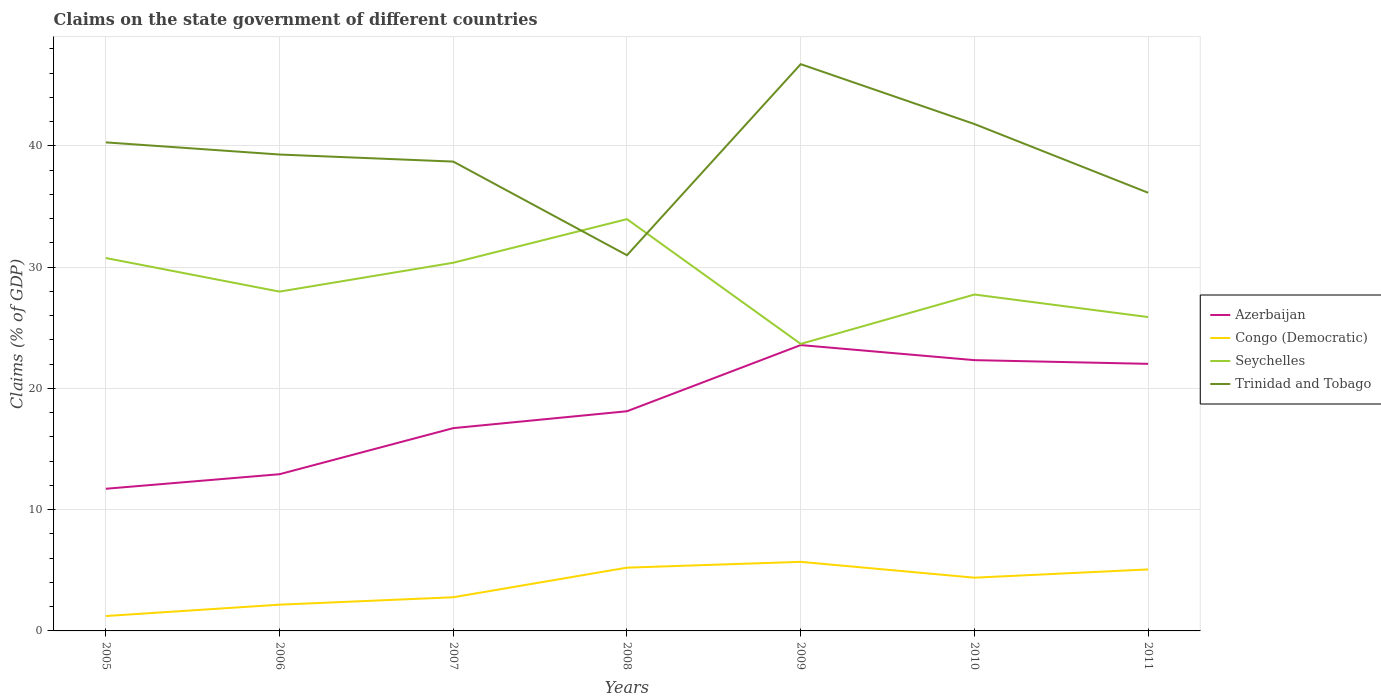How many different coloured lines are there?
Your response must be concise. 4. Does the line corresponding to Congo (Democratic) intersect with the line corresponding to Azerbaijan?
Your response must be concise. No. Is the number of lines equal to the number of legend labels?
Your response must be concise. Yes. Across all years, what is the maximum percentage of GDP claimed on the state government in Congo (Democratic)?
Provide a short and direct response. 1.23. What is the total percentage of GDP claimed on the state government in Trinidad and Tobago in the graph?
Your response must be concise. 2.57. What is the difference between the highest and the second highest percentage of GDP claimed on the state government in Trinidad and Tobago?
Make the answer very short. 15.76. What is the difference between the highest and the lowest percentage of GDP claimed on the state government in Congo (Democratic)?
Provide a succinct answer. 4. How many lines are there?
Keep it short and to the point. 4. How many years are there in the graph?
Your answer should be compact. 7. What is the difference between two consecutive major ticks on the Y-axis?
Offer a terse response. 10. Does the graph contain any zero values?
Keep it short and to the point. No. Where does the legend appear in the graph?
Provide a succinct answer. Center right. What is the title of the graph?
Give a very brief answer. Claims on the state government of different countries. What is the label or title of the Y-axis?
Keep it short and to the point. Claims (% of GDP). What is the Claims (% of GDP) of Azerbaijan in 2005?
Your answer should be very brief. 11.73. What is the Claims (% of GDP) in Congo (Democratic) in 2005?
Ensure brevity in your answer.  1.23. What is the Claims (% of GDP) in Seychelles in 2005?
Offer a very short reply. 30.76. What is the Claims (% of GDP) of Trinidad and Tobago in 2005?
Keep it short and to the point. 40.29. What is the Claims (% of GDP) in Azerbaijan in 2006?
Your answer should be compact. 12.93. What is the Claims (% of GDP) of Congo (Democratic) in 2006?
Give a very brief answer. 2.16. What is the Claims (% of GDP) of Seychelles in 2006?
Make the answer very short. 27.99. What is the Claims (% of GDP) in Trinidad and Tobago in 2006?
Ensure brevity in your answer.  39.29. What is the Claims (% of GDP) of Azerbaijan in 2007?
Your answer should be compact. 16.73. What is the Claims (% of GDP) in Congo (Democratic) in 2007?
Give a very brief answer. 2.78. What is the Claims (% of GDP) in Seychelles in 2007?
Your answer should be compact. 30.37. What is the Claims (% of GDP) in Trinidad and Tobago in 2007?
Give a very brief answer. 38.71. What is the Claims (% of GDP) of Azerbaijan in 2008?
Offer a terse response. 18.12. What is the Claims (% of GDP) of Congo (Democratic) in 2008?
Offer a very short reply. 5.22. What is the Claims (% of GDP) of Seychelles in 2008?
Give a very brief answer. 33.96. What is the Claims (% of GDP) in Trinidad and Tobago in 2008?
Provide a short and direct response. 30.99. What is the Claims (% of GDP) in Azerbaijan in 2009?
Offer a very short reply. 23.58. What is the Claims (% of GDP) in Congo (Democratic) in 2009?
Your answer should be compact. 5.7. What is the Claims (% of GDP) of Seychelles in 2009?
Your answer should be compact. 23.67. What is the Claims (% of GDP) in Trinidad and Tobago in 2009?
Provide a short and direct response. 46.75. What is the Claims (% of GDP) in Azerbaijan in 2010?
Your answer should be compact. 22.33. What is the Claims (% of GDP) in Congo (Democratic) in 2010?
Make the answer very short. 4.39. What is the Claims (% of GDP) in Seychelles in 2010?
Provide a short and direct response. 27.75. What is the Claims (% of GDP) in Trinidad and Tobago in 2010?
Provide a succinct answer. 41.81. What is the Claims (% of GDP) of Azerbaijan in 2011?
Provide a short and direct response. 22.03. What is the Claims (% of GDP) of Congo (Democratic) in 2011?
Your response must be concise. 5.07. What is the Claims (% of GDP) of Seychelles in 2011?
Ensure brevity in your answer.  25.89. What is the Claims (% of GDP) of Trinidad and Tobago in 2011?
Ensure brevity in your answer.  36.14. Across all years, what is the maximum Claims (% of GDP) in Azerbaijan?
Your answer should be compact. 23.58. Across all years, what is the maximum Claims (% of GDP) in Congo (Democratic)?
Give a very brief answer. 5.7. Across all years, what is the maximum Claims (% of GDP) in Seychelles?
Make the answer very short. 33.96. Across all years, what is the maximum Claims (% of GDP) in Trinidad and Tobago?
Offer a very short reply. 46.75. Across all years, what is the minimum Claims (% of GDP) of Azerbaijan?
Make the answer very short. 11.73. Across all years, what is the minimum Claims (% of GDP) of Congo (Democratic)?
Make the answer very short. 1.23. Across all years, what is the minimum Claims (% of GDP) in Seychelles?
Your answer should be compact. 23.67. Across all years, what is the minimum Claims (% of GDP) of Trinidad and Tobago?
Offer a terse response. 30.99. What is the total Claims (% of GDP) of Azerbaijan in the graph?
Provide a succinct answer. 127.43. What is the total Claims (% of GDP) of Congo (Democratic) in the graph?
Offer a terse response. 26.55. What is the total Claims (% of GDP) of Seychelles in the graph?
Your response must be concise. 200.38. What is the total Claims (% of GDP) of Trinidad and Tobago in the graph?
Your response must be concise. 273.98. What is the difference between the Claims (% of GDP) in Azerbaijan in 2005 and that in 2006?
Your answer should be very brief. -1.2. What is the difference between the Claims (% of GDP) in Congo (Democratic) in 2005 and that in 2006?
Your response must be concise. -0.94. What is the difference between the Claims (% of GDP) of Seychelles in 2005 and that in 2006?
Your response must be concise. 2.77. What is the difference between the Claims (% of GDP) in Trinidad and Tobago in 2005 and that in 2006?
Your response must be concise. 1. What is the difference between the Claims (% of GDP) in Azerbaijan in 2005 and that in 2007?
Provide a short and direct response. -5. What is the difference between the Claims (% of GDP) of Congo (Democratic) in 2005 and that in 2007?
Offer a terse response. -1.55. What is the difference between the Claims (% of GDP) of Seychelles in 2005 and that in 2007?
Give a very brief answer. 0.39. What is the difference between the Claims (% of GDP) of Trinidad and Tobago in 2005 and that in 2007?
Your answer should be very brief. 1.58. What is the difference between the Claims (% of GDP) in Azerbaijan in 2005 and that in 2008?
Offer a terse response. -6.39. What is the difference between the Claims (% of GDP) in Congo (Democratic) in 2005 and that in 2008?
Offer a very short reply. -3.99. What is the difference between the Claims (% of GDP) of Seychelles in 2005 and that in 2008?
Offer a terse response. -3.21. What is the difference between the Claims (% of GDP) of Trinidad and Tobago in 2005 and that in 2008?
Your response must be concise. 9.31. What is the difference between the Claims (% of GDP) of Azerbaijan in 2005 and that in 2009?
Provide a short and direct response. -11.85. What is the difference between the Claims (% of GDP) in Congo (Democratic) in 2005 and that in 2009?
Keep it short and to the point. -4.47. What is the difference between the Claims (% of GDP) in Seychelles in 2005 and that in 2009?
Your answer should be compact. 7.08. What is the difference between the Claims (% of GDP) of Trinidad and Tobago in 2005 and that in 2009?
Ensure brevity in your answer.  -6.45. What is the difference between the Claims (% of GDP) of Azerbaijan in 2005 and that in 2010?
Offer a very short reply. -10.61. What is the difference between the Claims (% of GDP) of Congo (Democratic) in 2005 and that in 2010?
Make the answer very short. -3.16. What is the difference between the Claims (% of GDP) in Seychelles in 2005 and that in 2010?
Make the answer very short. 3.01. What is the difference between the Claims (% of GDP) of Trinidad and Tobago in 2005 and that in 2010?
Ensure brevity in your answer.  -1.51. What is the difference between the Claims (% of GDP) of Azerbaijan in 2005 and that in 2011?
Your answer should be very brief. -10.3. What is the difference between the Claims (% of GDP) in Congo (Democratic) in 2005 and that in 2011?
Your response must be concise. -3.84. What is the difference between the Claims (% of GDP) of Seychelles in 2005 and that in 2011?
Your response must be concise. 4.87. What is the difference between the Claims (% of GDP) of Trinidad and Tobago in 2005 and that in 2011?
Make the answer very short. 4.15. What is the difference between the Claims (% of GDP) in Azerbaijan in 2006 and that in 2007?
Provide a succinct answer. -3.8. What is the difference between the Claims (% of GDP) of Congo (Democratic) in 2006 and that in 2007?
Provide a short and direct response. -0.61. What is the difference between the Claims (% of GDP) in Seychelles in 2006 and that in 2007?
Ensure brevity in your answer.  -2.38. What is the difference between the Claims (% of GDP) in Trinidad and Tobago in 2006 and that in 2007?
Offer a terse response. 0.58. What is the difference between the Claims (% of GDP) of Azerbaijan in 2006 and that in 2008?
Offer a terse response. -5.19. What is the difference between the Claims (% of GDP) in Congo (Democratic) in 2006 and that in 2008?
Keep it short and to the point. -3.05. What is the difference between the Claims (% of GDP) of Seychelles in 2006 and that in 2008?
Your response must be concise. -5.98. What is the difference between the Claims (% of GDP) of Trinidad and Tobago in 2006 and that in 2008?
Your response must be concise. 8.31. What is the difference between the Claims (% of GDP) in Azerbaijan in 2006 and that in 2009?
Offer a terse response. -10.65. What is the difference between the Claims (% of GDP) of Congo (Democratic) in 2006 and that in 2009?
Your response must be concise. -3.53. What is the difference between the Claims (% of GDP) of Seychelles in 2006 and that in 2009?
Your answer should be very brief. 4.31. What is the difference between the Claims (% of GDP) in Trinidad and Tobago in 2006 and that in 2009?
Provide a short and direct response. -7.45. What is the difference between the Claims (% of GDP) of Azerbaijan in 2006 and that in 2010?
Offer a very short reply. -9.41. What is the difference between the Claims (% of GDP) in Congo (Democratic) in 2006 and that in 2010?
Your answer should be compact. -2.23. What is the difference between the Claims (% of GDP) in Seychelles in 2006 and that in 2010?
Your answer should be compact. 0.24. What is the difference between the Claims (% of GDP) of Trinidad and Tobago in 2006 and that in 2010?
Provide a short and direct response. -2.51. What is the difference between the Claims (% of GDP) in Azerbaijan in 2006 and that in 2011?
Keep it short and to the point. -9.1. What is the difference between the Claims (% of GDP) of Congo (Democratic) in 2006 and that in 2011?
Provide a short and direct response. -2.91. What is the difference between the Claims (% of GDP) in Seychelles in 2006 and that in 2011?
Give a very brief answer. 2.1. What is the difference between the Claims (% of GDP) of Trinidad and Tobago in 2006 and that in 2011?
Keep it short and to the point. 3.15. What is the difference between the Claims (% of GDP) in Azerbaijan in 2007 and that in 2008?
Give a very brief answer. -1.39. What is the difference between the Claims (% of GDP) of Congo (Democratic) in 2007 and that in 2008?
Your answer should be compact. -2.44. What is the difference between the Claims (% of GDP) of Seychelles in 2007 and that in 2008?
Your response must be concise. -3.6. What is the difference between the Claims (% of GDP) in Trinidad and Tobago in 2007 and that in 2008?
Your answer should be compact. 7.72. What is the difference between the Claims (% of GDP) of Azerbaijan in 2007 and that in 2009?
Provide a short and direct response. -6.85. What is the difference between the Claims (% of GDP) of Congo (Democratic) in 2007 and that in 2009?
Provide a succinct answer. -2.92. What is the difference between the Claims (% of GDP) in Seychelles in 2007 and that in 2009?
Ensure brevity in your answer.  6.69. What is the difference between the Claims (% of GDP) in Trinidad and Tobago in 2007 and that in 2009?
Make the answer very short. -8.03. What is the difference between the Claims (% of GDP) of Azerbaijan in 2007 and that in 2010?
Keep it short and to the point. -5.61. What is the difference between the Claims (% of GDP) of Congo (Democratic) in 2007 and that in 2010?
Your answer should be compact. -1.61. What is the difference between the Claims (% of GDP) in Seychelles in 2007 and that in 2010?
Keep it short and to the point. 2.62. What is the difference between the Claims (% of GDP) in Trinidad and Tobago in 2007 and that in 2010?
Ensure brevity in your answer.  -3.1. What is the difference between the Claims (% of GDP) of Azerbaijan in 2007 and that in 2011?
Ensure brevity in your answer.  -5.3. What is the difference between the Claims (% of GDP) of Congo (Democratic) in 2007 and that in 2011?
Your answer should be very brief. -2.3. What is the difference between the Claims (% of GDP) of Seychelles in 2007 and that in 2011?
Your answer should be compact. 4.48. What is the difference between the Claims (% of GDP) in Trinidad and Tobago in 2007 and that in 2011?
Your response must be concise. 2.57. What is the difference between the Claims (% of GDP) in Azerbaijan in 2008 and that in 2009?
Offer a terse response. -5.46. What is the difference between the Claims (% of GDP) in Congo (Democratic) in 2008 and that in 2009?
Your response must be concise. -0.48. What is the difference between the Claims (% of GDP) of Seychelles in 2008 and that in 2009?
Your response must be concise. 10.29. What is the difference between the Claims (% of GDP) of Trinidad and Tobago in 2008 and that in 2009?
Give a very brief answer. -15.76. What is the difference between the Claims (% of GDP) of Azerbaijan in 2008 and that in 2010?
Ensure brevity in your answer.  -4.22. What is the difference between the Claims (% of GDP) of Congo (Democratic) in 2008 and that in 2010?
Offer a very short reply. 0.83. What is the difference between the Claims (% of GDP) in Seychelles in 2008 and that in 2010?
Provide a short and direct response. 6.22. What is the difference between the Claims (% of GDP) of Trinidad and Tobago in 2008 and that in 2010?
Give a very brief answer. -10.82. What is the difference between the Claims (% of GDP) of Azerbaijan in 2008 and that in 2011?
Provide a succinct answer. -3.91. What is the difference between the Claims (% of GDP) in Congo (Democratic) in 2008 and that in 2011?
Your response must be concise. 0.15. What is the difference between the Claims (% of GDP) of Seychelles in 2008 and that in 2011?
Offer a very short reply. 8.08. What is the difference between the Claims (% of GDP) in Trinidad and Tobago in 2008 and that in 2011?
Your answer should be compact. -5.15. What is the difference between the Claims (% of GDP) of Azerbaijan in 2009 and that in 2010?
Ensure brevity in your answer.  1.24. What is the difference between the Claims (% of GDP) in Congo (Democratic) in 2009 and that in 2010?
Provide a short and direct response. 1.31. What is the difference between the Claims (% of GDP) of Seychelles in 2009 and that in 2010?
Give a very brief answer. -4.07. What is the difference between the Claims (% of GDP) in Trinidad and Tobago in 2009 and that in 2010?
Provide a short and direct response. 4.94. What is the difference between the Claims (% of GDP) in Azerbaijan in 2009 and that in 2011?
Ensure brevity in your answer.  1.55. What is the difference between the Claims (% of GDP) of Congo (Democratic) in 2009 and that in 2011?
Offer a terse response. 0.63. What is the difference between the Claims (% of GDP) in Seychelles in 2009 and that in 2011?
Make the answer very short. -2.21. What is the difference between the Claims (% of GDP) in Trinidad and Tobago in 2009 and that in 2011?
Offer a very short reply. 10.6. What is the difference between the Claims (% of GDP) in Azerbaijan in 2010 and that in 2011?
Make the answer very short. 0.31. What is the difference between the Claims (% of GDP) of Congo (Democratic) in 2010 and that in 2011?
Your answer should be very brief. -0.68. What is the difference between the Claims (% of GDP) of Seychelles in 2010 and that in 2011?
Provide a short and direct response. 1.86. What is the difference between the Claims (% of GDP) in Trinidad and Tobago in 2010 and that in 2011?
Make the answer very short. 5.67. What is the difference between the Claims (% of GDP) of Azerbaijan in 2005 and the Claims (% of GDP) of Congo (Democratic) in 2006?
Your response must be concise. 9.56. What is the difference between the Claims (% of GDP) of Azerbaijan in 2005 and the Claims (% of GDP) of Seychelles in 2006?
Ensure brevity in your answer.  -16.26. What is the difference between the Claims (% of GDP) in Azerbaijan in 2005 and the Claims (% of GDP) in Trinidad and Tobago in 2006?
Provide a short and direct response. -27.57. What is the difference between the Claims (% of GDP) in Congo (Democratic) in 2005 and the Claims (% of GDP) in Seychelles in 2006?
Provide a succinct answer. -26.76. What is the difference between the Claims (% of GDP) in Congo (Democratic) in 2005 and the Claims (% of GDP) in Trinidad and Tobago in 2006?
Keep it short and to the point. -38.06. What is the difference between the Claims (% of GDP) in Seychelles in 2005 and the Claims (% of GDP) in Trinidad and Tobago in 2006?
Your answer should be very brief. -8.54. What is the difference between the Claims (% of GDP) in Azerbaijan in 2005 and the Claims (% of GDP) in Congo (Democratic) in 2007?
Keep it short and to the point. 8.95. What is the difference between the Claims (% of GDP) of Azerbaijan in 2005 and the Claims (% of GDP) of Seychelles in 2007?
Make the answer very short. -18.64. What is the difference between the Claims (% of GDP) of Azerbaijan in 2005 and the Claims (% of GDP) of Trinidad and Tobago in 2007?
Give a very brief answer. -26.99. What is the difference between the Claims (% of GDP) in Congo (Democratic) in 2005 and the Claims (% of GDP) in Seychelles in 2007?
Your answer should be compact. -29.14. What is the difference between the Claims (% of GDP) of Congo (Democratic) in 2005 and the Claims (% of GDP) of Trinidad and Tobago in 2007?
Your answer should be compact. -37.48. What is the difference between the Claims (% of GDP) of Seychelles in 2005 and the Claims (% of GDP) of Trinidad and Tobago in 2007?
Your answer should be compact. -7.95. What is the difference between the Claims (% of GDP) in Azerbaijan in 2005 and the Claims (% of GDP) in Congo (Democratic) in 2008?
Your answer should be compact. 6.51. What is the difference between the Claims (% of GDP) in Azerbaijan in 2005 and the Claims (% of GDP) in Seychelles in 2008?
Make the answer very short. -22.24. What is the difference between the Claims (% of GDP) in Azerbaijan in 2005 and the Claims (% of GDP) in Trinidad and Tobago in 2008?
Keep it short and to the point. -19.26. What is the difference between the Claims (% of GDP) in Congo (Democratic) in 2005 and the Claims (% of GDP) in Seychelles in 2008?
Ensure brevity in your answer.  -32.73. What is the difference between the Claims (% of GDP) in Congo (Democratic) in 2005 and the Claims (% of GDP) in Trinidad and Tobago in 2008?
Ensure brevity in your answer.  -29.76. What is the difference between the Claims (% of GDP) of Seychelles in 2005 and the Claims (% of GDP) of Trinidad and Tobago in 2008?
Your response must be concise. -0.23. What is the difference between the Claims (% of GDP) in Azerbaijan in 2005 and the Claims (% of GDP) in Congo (Democratic) in 2009?
Offer a terse response. 6.03. What is the difference between the Claims (% of GDP) of Azerbaijan in 2005 and the Claims (% of GDP) of Seychelles in 2009?
Provide a short and direct response. -11.95. What is the difference between the Claims (% of GDP) of Azerbaijan in 2005 and the Claims (% of GDP) of Trinidad and Tobago in 2009?
Give a very brief answer. -35.02. What is the difference between the Claims (% of GDP) in Congo (Democratic) in 2005 and the Claims (% of GDP) in Seychelles in 2009?
Keep it short and to the point. -22.44. What is the difference between the Claims (% of GDP) in Congo (Democratic) in 2005 and the Claims (% of GDP) in Trinidad and Tobago in 2009?
Your response must be concise. -45.52. What is the difference between the Claims (% of GDP) in Seychelles in 2005 and the Claims (% of GDP) in Trinidad and Tobago in 2009?
Provide a succinct answer. -15.99. What is the difference between the Claims (% of GDP) in Azerbaijan in 2005 and the Claims (% of GDP) in Congo (Democratic) in 2010?
Provide a succinct answer. 7.33. What is the difference between the Claims (% of GDP) of Azerbaijan in 2005 and the Claims (% of GDP) of Seychelles in 2010?
Provide a short and direct response. -16.02. What is the difference between the Claims (% of GDP) of Azerbaijan in 2005 and the Claims (% of GDP) of Trinidad and Tobago in 2010?
Offer a very short reply. -30.08. What is the difference between the Claims (% of GDP) in Congo (Democratic) in 2005 and the Claims (% of GDP) in Seychelles in 2010?
Make the answer very short. -26.52. What is the difference between the Claims (% of GDP) of Congo (Democratic) in 2005 and the Claims (% of GDP) of Trinidad and Tobago in 2010?
Provide a succinct answer. -40.58. What is the difference between the Claims (% of GDP) in Seychelles in 2005 and the Claims (% of GDP) in Trinidad and Tobago in 2010?
Give a very brief answer. -11.05. What is the difference between the Claims (% of GDP) of Azerbaijan in 2005 and the Claims (% of GDP) of Congo (Democratic) in 2011?
Your response must be concise. 6.65. What is the difference between the Claims (% of GDP) in Azerbaijan in 2005 and the Claims (% of GDP) in Seychelles in 2011?
Your response must be concise. -14.16. What is the difference between the Claims (% of GDP) of Azerbaijan in 2005 and the Claims (% of GDP) of Trinidad and Tobago in 2011?
Give a very brief answer. -24.42. What is the difference between the Claims (% of GDP) of Congo (Democratic) in 2005 and the Claims (% of GDP) of Seychelles in 2011?
Provide a short and direct response. -24.66. What is the difference between the Claims (% of GDP) of Congo (Democratic) in 2005 and the Claims (% of GDP) of Trinidad and Tobago in 2011?
Give a very brief answer. -34.91. What is the difference between the Claims (% of GDP) of Seychelles in 2005 and the Claims (% of GDP) of Trinidad and Tobago in 2011?
Your answer should be very brief. -5.38. What is the difference between the Claims (% of GDP) in Azerbaijan in 2006 and the Claims (% of GDP) in Congo (Democratic) in 2007?
Offer a terse response. 10.15. What is the difference between the Claims (% of GDP) of Azerbaijan in 2006 and the Claims (% of GDP) of Seychelles in 2007?
Ensure brevity in your answer.  -17.44. What is the difference between the Claims (% of GDP) of Azerbaijan in 2006 and the Claims (% of GDP) of Trinidad and Tobago in 2007?
Your answer should be very brief. -25.79. What is the difference between the Claims (% of GDP) of Congo (Democratic) in 2006 and the Claims (% of GDP) of Seychelles in 2007?
Provide a succinct answer. -28.2. What is the difference between the Claims (% of GDP) in Congo (Democratic) in 2006 and the Claims (% of GDP) in Trinidad and Tobago in 2007?
Your answer should be very brief. -36.55. What is the difference between the Claims (% of GDP) of Seychelles in 2006 and the Claims (% of GDP) of Trinidad and Tobago in 2007?
Your answer should be very brief. -10.72. What is the difference between the Claims (% of GDP) in Azerbaijan in 2006 and the Claims (% of GDP) in Congo (Democratic) in 2008?
Ensure brevity in your answer.  7.71. What is the difference between the Claims (% of GDP) of Azerbaijan in 2006 and the Claims (% of GDP) of Seychelles in 2008?
Your answer should be very brief. -21.04. What is the difference between the Claims (% of GDP) of Azerbaijan in 2006 and the Claims (% of GDP) of Trinidad and Tobago in 2008?
Provide a succinct answer. -18.06. What is the difference between the Claims (% of GDP) of Congo (Democratic) in 2006 and the Claims (% of GDP) of Seychelles in 2008?
Keep it short and to the point. -31.8. What is the difference between the Claims (% of GDP) of Congo (Democratic) in 2006 and the Claims (% of GDP) of Trinidad and Tobago in 2008?
Provide a short and direct response. -28.82. What is the difference between the Claims (% of GDP) in Seychelles in 2006 and the Claims (% of GDP) in Trinidad and Tobago in 2008?
Your answer should be compact. -3. What is the difference between the Claims (% of GDP) in Azerbaijan in 2006 and the Claims (% of GDP) in Congo (Democratic) in 2009?
Offer a terse response. 7.23. What is the difference between the Claims (% of GDP) of Azerbaijan in 2006 and the Claims (% of GDP) of Seychelles in 2009?
Offer a very short reply. -10.75. What is the difference between the Claims (% of GDP) in Azerbaijan in 2006 and the Claims (% of GDP) in Trinidad and Tobago in 2009?
Ensure brevity in your answer.  -33.82. What is the difference between the Claims (% of GDP) in Congo (Democratic) in 2006 and the Claims (% of GDP) in Seychelles in 2009?
Your response must be concise. -21.51. What is the difference between the Claims (% of GDP) in Congo (Democratic) in 2006 and the Claims (% of GDP) in Trinidad and Tobago in 2009?
Keep it short and to the point. -44.58. What is the difference between the Claims (% of GDP) in Seychelles in 2006 and the Claims (% of GDP) in Trinidad and Tobago in 2009?
Your answer should be compact. -18.76. What is the difference between the Claims (% of GDP) of Azerbaijan in 2006 and the Claims (% of GDP) of Congo (Democratic) in 2010?
Your answer should be compact. 8.53. What is the difference between the Claims (% of GDP) of Azerbaijan in 2006 and the Claims (% of GDP) of Seychelles in 2010?
Your answer should be compact. -14.82. What is the difference between the Claims (% of GDP) of Azerbaijan in 2006 and the Claims (% of GDP) of Trinidad and Tobago in 2010?
Your response must be concise. -28.88. What is the difference between the Claims (% of GDP) in Congo (Democratic) in 2006 and the Claims (% of GDP) in Seychelles in 2010?
Your response must be concise. -25.58. What is the difference between the Claims (% of GDP) of Congo (Democratic) in 2006 and the Claims (% of GDP) of Trinidad and Tobago in 2010?
Your response must be concise. -39.64. What is the difference between the Claims (% of GDP) of Seychelles in 2006 and the Claims (% of GDP) of Trinidad and Tobago in 2010?
Your answer should be very brief. -13.82. What is the difference between the Claims (% of GDP) of Azerbaijan in 2006 and the Claims (% of GDP) of Congo (Democratic) in 2011?
Your answer should be very brief. 7.85. What is the difference between the Claims (% of GDP) of Azerbaijan in 2006 and the Claims (% of GDP) of Seychelles in 2011?
Your answer should be very brief. -12.96. What is the difference between the Claims (% of GDP) in Azerbaijan in 2006 and the Claims (% of GDP) in Trinidad and Tobago in 2011?
Provide a succinct answer. -23.22. What is the difference between the Claims (% of GDP) of Congo (Democratic) in 2006 and the Claims (% of GDP) of Seychelles in 2011?
Offer a terse response. -23.72. What is the difference between the Claims (% of GDP) in Congo (Democratic) in 2006 and the Claims (% of GDP) in Trinidad and Tobago in 2011?
Make the answer very short. -33.98. What is the difference between the Claims (% of GDP) of Seychelles in 2006 and the Claims (% of GDP) of Trinidad and Tobago in 2011?
Ensure brevity in your answer.  -8.15. What is the difference between the Claims (% of GDP) in Azerbaijan in 2007 and the Claims (% of GDP) in Congo (Democratic) in 2008?
Keep it short and to the point. 11.51. What is the difference between the Claims (% of GDP) of Azerbaijan in 2007 and the Claims (% of GDP) of Seychelles in 2008?
Make the answer very short. -17.24. What is the difference between the Claims (% of GDP) of Azerbaijan in 2007 and the Claims (% of GDP) of Trinidad and Tobago in 2008?
Offer a very short reply. -14.26. What is the difference between the Claims (% of GDP) of Congo (Democratic) in 2007 and the Claims (% of GDP) of Seychelles in 2008?
Make the answer very short. -31.19. What is the difference between the Claims (% of GDP) of Congo (Democratic) in 2007 and the Claims (% of GDP) of Trinidad and Tobago in 2008?
Make the answer very short. -28.21. What is the difference between the Claims (% of GDP) in Seychelles in 2007 and the Claims (% of GDP) in Trinidad and Tobago in 2008?
Your response must be concise. -0.62. What is the difference between the Claims (% of GDP) of Azerbaijan in 2007 and the Claims (% of GDP) of Congo (Democratic) in 2009?
Provide a short and direct response. 11.03. What is the difference between the Claims (% of GDP) in Azerbaijan in 2007 and the Claims (% of GDP) in Seychelles in 2009?
Offer a very short reply. -6.95. What is the difference between the Claims (% of GDP) of Azerbaijan in 2007 and the Claims (% of GDP) of Trinidad and Tobago in 2009?
Ensure brevity in your answer.  -30.02. What is the difference between the Claims (% of GDP) in Congo (Democratic) in 2007 and the Claims (% of GDP) in Seychelles in 2009?
Keep it short and to the point. -20.9. What is the difference between the Claims (% of GDP) in Congo (Democratic) in 2007 and the Claims (% of GDP) in Trinidad and Tobago in 2009?
Your answer should be compact. -43.97. What is the difference between the Claims (% of GDP) of Seychelles in 2007 and the Claims (% of GDP) of Trinidad and Tobago in 2009?
Your answer should be very brief. -16.38. What is the difference between the Claims (% of GDP) of Azerbaijan in 2007 and the Claims (% of GDP) of Congo (Democratic) in 2010?
Offer a very short reply. 12.33. What is the difference between the Claims (% of GDP) of Azerbaijan in 2007 and the Claims (% of GDP) of Seychelles in 2010?
Your answer should be very brief. -11.02. What is the difference between the Claims (% of GDP) in Azerbaijan in 2007 and the Claims (% of GDP) in Trinidad and Tobago in 2010?
Offer a terse response. -25.08. What is the difference between the Claims (% of GDP) of Congo (Democratic) in 2007 and the Claims (% of GDP) of Seychelles in 2010?
Give a very brief answer. -24.97. What is the difference between the Claims (% of GDP) of Congo (Democratic) in 2007 and the Claims (% of GDP) of Trinidad and Tobago in 2010?
Ensure brevity in your answer.  -39.03. What is the difference between the Claims (% of GDP) of Seychelles in 2007 and the Claims (% of GDP) of Trinidad and Tobago in 2010?
Provide a succinct answer. -11.44. What is the difference between the Claims (% of GDP) in Azerbaijan in 2007 and the Claims (% of GDP) in Congo (Democratic) in 2011?
Provide a succinct answer. 11.65. What is the difference between the Claims (% of GDP) in Azerbaijan in 2007 and the Claims (% of GDP) in Seychelles in 2011?
Keep it short and to the point. -9.16. What is the difference between the Claims (% of GDP) of Azerbaijan in 2007 and the Claims (% of GDP) of Trinidad and Tobago in 2011?
Offer a very short reply. -19.42. What is the difference between the Claims (% of GDP) in Congo (Democratic) in 2007 and the Claims (% of GDP) in Seychelles in 2011?
Your response must be concise. -23.11. What is the difference between the Claims (% of GDP) in Congo (Democratic) in 2007 and the Claims (% of GDP) in Trinidad and Tobago in 2011?
Provide a succinct answer. -33.36. What is the difference between the Claims (% of GDP) of Seychelles in 2007 and the Claims (% of GDP) of Trinidad and Tobago in 2011?
Offer a very short reply. -5.77. What is the difference between the Claims (% of GDP) in Azerbaijan in 2008 and the Claims (% of GDP) in Congo (Democratic) in 2009?
Keep it short and to the point. 12.42. What is the difference between the Claims (% of GDP) of Azerbaijan in 2008 and the Claims (% of GDP) of Seychelles in 2009?
Keep it short and to the point. -5.56. What is the difference between the Claims (% of GDP) in Azerbaijan in 2008 and the Claims (% of GDP) in Trinidad and Tobago in 2009?
Make the answer very short. -28.63. What is the difference between the Claims (% of GDP) of Congo (Democratic) in 2008 and the Claims (% of GDP) of Seychelles in 2009?
Offer a very short reply. -18.46. What is the difference between the Claims (% of GDP) of Congo (Democratic) in 2008 and the Claims (% of GDP) of Trinidad and Tobago in 2009?
Your answer should be very brief. -41.53. What is the difference between the Claims (% of GDP) of Seychelles in 2008 and the Claims (% of GDP) of Trinidad and Tobago in 2009?
Ensure brevity in your answer.  -12.78. What is the difference between the Claims (% of GDP) of Azerbaijan in 2008 and the Claims (% of GDP) of Congo (Democratic) in 2010?
Keep it short and to the point. 13.73. What is the difference between the Claims (% of GDP) in Azerbaijan in 2008 and the Claims (% of GDP) in Seychelles in 2010?
Ensure brevity in your answer.  -9.63. What is the difference between the Claims (% of GDP) in Azerbaijan in 2008 and the Claims (% of GDP) in Trinidad and Tobago in 2010?
Offer a very short reply. -23.69. What is the difference between the Claims (% of GDP) in Congo (Democratic) in 2008 and the Claims (% of GDP) in Seychelles in 2010?
Your response must be concise. -22.53. What is the difference between the Claims (% of GDP) in Congo (Democratic) in 2008 and the Claims (% of GDP) in Trinidad and Tobago in 2010?
Your answer should be very brief. -36.59. What is the difference between the Claims (% of GDP) in Seychelles in 2008 and the Claims (% of GDP) in Trinidad and Tobago in 2010?
Offer a terse response. -7.84. What is the difference between the Claims (% of GDP) in Azerbaijan in 2008 and the Claims (% of GDP) in Congo (Democratic) in 2011?
Provide a succinct answer. 13.05. What is the difference between the Claims (% of GDP) in Azerbaijan in 2008 and the Claims (% of GDP) in Seychelles in 2011?
Keep it short and to the point. -7.77. What is the difference between the Claims (% of GDP) in Azerbaijan in 2008 and the Claims (% of GDP) in Trinidad and Tobago in 2011?
Give a very brief answer. -18.02. What is the difference between the Claims (% of GDP) in Congo (Democratic) in 2008 and the Claims (% of GDP) in Seychelles in 2011?
Offer a very short reply. -20.67. What is the difference between the Claims (% of GDP) in Congo (Democratic) in 2008 and the Claims (% of GDP) in Trinidad and Tobago in 2011?
Offer a terse response. -30.92. What is the difference between the Claims (% of GDP) of Seychelles in 2008 and the Claims (% of GDP) of Trinidad and Tobago in 2011?
Keep it short and to the point. -2.18. What is the difference between the Claims (% of GDP) of Azerbaijan in 2009 and the Claims (% of GDP) of Congo (Democratic) in 2010?
Your response must be concise. 19.18. What is the difference between the Claims (% of GDP) in Azerbaijan in 2009 and the Claims (% of GDP) in Seychelles in 2010?
Ensure brevity in your answer.  -4.17. What is the difference between the Claims (% of GDP) in Azerbaijan in 2009 and the Claims (% of GDP) in Trinidad and Tobago in 2010?
Make the answer very short. -18.23. What is the difference between the Claims (% of GDP) of Congo (Democratic) in 2009 and the Claims (% of GDP) of Seychelles in 2010?
Provide a succinct answer. -22.05. What is the difference between the Claims (% of GDP) of Congo (Democratic) in 2009 and the Claims (% of GDP) of Trinidad and Tobago in 2010?
Your answer should be compact. -36.11. What is the difference between the Claims (% of GDP) in Seychelles in 2009 and the Claims (% of GDP) in Trinidad and Tobago in 2010?
Provide a succinct answer. -18.13. What is the difference between the Claims (% of GDP) in Azerbaijan in 2009 and the Claims (% of GDP) in Congo (Democratic) in 2011?
Give a very brief answer. 18.5. What is the difference between the Claims (% of GDP) in Azerbaijan in 2009 and the Claims (% of GDP) in Seychelles in 2011?
Your answer should be compact. -2.31. What is the difference between the Claims (% of GDP) of Azerbaijan in 2009 and the Claims (% of GDP) of Trinidad and Tobago in 2011?
Your response must be concise. -12.57. What is the difference between the Claims (% of GDP) of Congo (Democratic) in 2009 and the Claims (% of GDP) of Seychelles in 2011?
Ensure brevity in your answer.  -20.19. What is the difference between the Claims (% of GDP) in Congo (Democratic) in 2009 and the Claims (% of GDP) in Trinidad and Tobago in 2011?
Provide a succinct answer. -30.44. What is the difference between the Claims (% of GDP) in Seychelles in 2009 and the Claims (% of GDP) in Trinidad and Tobago in 2011?
Your answer should be compact. -12.47. What is the difference between the Claims (% of GDP) in Azerbaijan in 2010 and the Claims (% of GDP) in Congo (Democratic) in 2011?
Offer a very short reply. 17.26. What is the difference between the Claims (% of GDP) of Azerbaijan in 2010 and the Claims (% of GDP) of Seychelles in 2011?
Your response must be concise. -3.55. What is the difference between the Claims (% of GDP) of Azerbaijan in 2010 and the Claims (% of GDP) of Trinidad and Tobago in 2011?
Provide a succinct answer. -13.81. What is the difference between the Claims (% of GDP) in Congo (Democratic) in 2010 and the Claims (% of GDP) in Seychelles in 2011?
Ensure brevity in your answer.  -21.5. What is the difference between the Claims (% of GDP) of Congo (Democratic) in 2010 and the Claims (% of GDP) of Trinidad and Tobago in 2011?
Provide a short and direct response. -31.75. What is the difference between the Claims (% of GDP) of Seychelles in 2010 and the Claims (% of GDP) of Trinidad and Tobago in 2011?
Your response must be concise. -8.4. What is the average Claims (% of GDP) of Azerbaijan per year?
Make the answer very short. 18.2. What is the average Claims (% of GDP) in Congo (Democratic) per year?
Your response must be concise. 3.79. What is the average Claims (% of GDP) of Seychelles per year?
Ensure brevity in your answer.  28.63. What is the average Claims (% of GDP) in Trinidad and Tobago per year?
Keep it short and to the point. 39.14. In the year 2005, what is the difference between the Claims (% of GDP) of Azerbaijan and Claims (% of GDP) of Congo (Democratic)?
Offer a very short reply. 10.5. In the year 2005, what is the difference between the Claims (% of GDP) of Azerbaijan and Claims (% of GDP) of Seychelles?
Provide a short and direct response. -19.03. In the year 2005, what is the difference between the Claims (% of GDP) in Azerbaijan and Claims (% of GDP) in Trinidad and Tobago?
Provide a succinct answer. -28.57. In the year 2005, what is the difference between the Claims (% of GDP) in Congo (Democratic) and Claims (% of GDP) in Seychelles?
Offer a very short reply. -29.53. In the year 2005, what is the difference between the Claims (% of GDP) in Congo (Democratic) and Claims (% of GDP) in Trinidad and Tobago?
Your answer should be very brief. -39.07. In the year 2005, what is the difference between the Claims (% of GDP) of Seychelles and Claims (% of GDP) of Trinidad and Tobago?
Give a very brief answer. -9.54. In the year 2006, what is the difference between the Claims (% of GDP) of Azerbaijan and Claims (% of GDP) of Congo (Democratic)?
Provide a short and direct response. 10.76. In the year 2006, what is the difference between the Claims (% of GDP) of Azerbaijan and Claims (% of GDP) of Seychelles?
Keep it short and to the point. -15.06. In the year 2006, what is the difference between the Claims (% of GDP) in Azerbaijan and Claims (% of GDP) in Trinidad and Tobago?
Provide a succinct answer. -26.37. In the year 2006, what is the difference between the Claims (% of GDP) in Congo (Democratic) and Claims (% of GDP) in Seychelles?
Ensure brevity in your answer.  -25.82. In the year 2006, what is the difference between the Claims (% of GDP) of Congo (Democratic) and Claims (% of GDP) of Trinidad and Tobago?
Give a very brief answer. -37.13. In the year 2006, what is the difference between the Claims (% of GDP) of Seychelles and Claims (% of GDP) of Trinidad and Tobago?
Keep it short and to the point. -11.31. In the year 2007, what is the difference between the Claims (% of GDP) of Azerbaijan and Claims (% of GDP) of Congo (Democratic)?
Your answer should be very brief. 13.95. In the year 2007, what is the difference between the Claims (% of GDP) of Azerbaijan and Claims (% of GDP) of Seychelles?
Provide a short and direct response. -13.64. In the year 2007, what is the difference between the Claims (% of GDP) of Azerbaijan and Claims (% of GDP) of Trinidad and Tobago?
Provide a short and direct response. -21.99. In the year 2007, what is the difference between the Claims (% of GDP) in Congo (Democratic) and Claims (% of GDP) in Seychelles?
Give a very brief answer. -27.59. In the year 2007, what is the difference between the Claims (% of GDP) of Congo (Democratic) and Claims (% of GDP) of Trinidad and Tobago?
Provide a succinct answer. -35.93. In the year 2007, what is the difference between the Claims (% of GDP) in Seychelles and Claims (% of GDP) in Trinidad and Tobago?
Give a very brief answer. -8.34. In the year 2008, what is the difference between the Claims (% of GDP) in Azerbaijan and Claims (% of GDP) in Congo (Democratic)?
Offer a terse response. 12.9. In the year 2008, what is the difference between the Claims (% of GDP) in Azerbaijan and Claims (% of GDP) in Seychelles?
Your answer should be compact. -15.85. In the year 2008, what is the difference between the Claims (% of GDP) of Azerbaijan and Claims (% of GDP) of Trinidad and Tobago?
Offer a terse response. -12.87. In the year 2008, what is the difference between the Claims (% of GDP) in Congo (Democratic) and Claims (% of GDP) in Seychelles?
Offer a very short reply. -28.75. In the year 2008, what is the difference between the Claims (% of GDP) of Congo (Democratic) and Claims (% of GDP) of Trinidad and Tobago?
Your answer should be compact. -25.77. In the year 2008, what is the difference between the Claims (% of GDP) in Seychelles and Claims (% of GDP) in Trinidad and Tobago?
Keep it short and to the point. 2.98. In the year 2009, what is the difference between the Claims (% of GDP) in Azerbaijan and Claims (% of GDP) in Congo (Democratic)?
Your answer should be compact. 17.88. In the year 2009, what is the difference between the Claims (% of GDP) in Azerbaijan and Claims (% of GDP) in Seychelles?
Give a very brief answer. -0.1. In the year 2009, what is the difference between the Claims (% of GDP) in Azerbaijan and Claims (% of GDP) in Trinidad and Tobago?
Ensure brevity in your answer.  -23.17. In the year 2009, what is the difference between the Claims (% of GDP) in Congo (Democratic) and Claims (% of GDP) in Seychelles?
Offer a terse response. -17.98. In the year 2009, what is the difference between the Claims (% of GDP) in Congo (Democratic) and Claims (% of GDP) in Trinidad and Tobago?
Provide a succinct answer. -41.05. In the year 2009, what is the difference between the Claims (% of GDP) in Seychelles and Claims (% of GDP) in Trinidad and Tobago?
Keep it short and to the point. -23.07. In the year 2010, what is the difference between the Claims (% of GDP) of Azerbaijan and Claims (% of GDP) of Congo (Democratic)?
Your response must be concise. 17.94. In the year 2010, what is the difference between the Claims (% of GDP) in Azerbaijan and Claims (% of GDP) in Seychelles?
Offer a very short reply. -5.41. In the year 2010, what is the difference between the Claims (% of GDP) of Azerbaijan and Claims (% of GDP) of Trinidad and Tobago?
Offer a terse response. -19.47. In the year 2010, what is the difference between the Claims (% of GDP) of Congo (Democratic) and Claims (% of GDP) of Seychelles?
Offer a very short reply. -23.35. In the year 2010, what is the difference between the Claims (% of GDP) of Congo (Democratic) and Claims (% of GDP) of Trinidad and Tobago?
Your answer should be compact. -37.42. In the year 2010, what is the difference between the Claims (% of GDP) of Seychelles and Claims (% of GDP) of Trinidad and Tobago?
Offer a very short reply. -14.06. In the year 2011, what is the difference between the Claims (% of GDP) of Azerbaijan and Claims (% of GDP) of Congo (Democratic)?
Keep it short and to the point. 16.96. In the year 2011, what is the difference between the Claims (% of GDP) of Azerbaijan and Claims (% of GDP) of Seychelles?
Provide a succinct answer. -3.86. In the year 2011, what is the difference between the Claims (% of GDP) in Azerbaijan and Claims (% of GDP) in Trinidad and Tobago?
Provide a short and direct response. -14.11. In the year 2011, what is the difference between the Claims (% of GDP) in Congo (Democratic) and Claims (% of GDP) in Seychelles?
Ensure brevity in your answer.  -20.82. In the year 2011, what is the difference between the Claims (% of GDP) in Congo (Democratic) and Claims (% of GDP) in Trinidad and Tobago?
Make the answer very short. -31.07. In the year 2011, what is the difference between the Claims (% of GDP) in Seychelles and Claims (% of GDP) in Trinidad and Tobago?
Provide a succinct answer. -10.25. What is the ratio of the Claims (% of GDP) in Azerbaijan in 2005 to that in 2006?
Offer a terse response. 0.91. What is the ratio of the Claims (% of GDP) of Congo (Democratic) in 2005 to that in 2006?
Provide a succinct answer. 0.57. What is the ratio of the Claims (% of GDP) of Seychelles in 2005 to that in 2006?
Provide a short and direct response. 1.1. What is the ratio of the Claims (% of GDP) of Trinidad and Tobago in 2005 to that in 2006?
Your response must be concise. 1.03. What is the ratio of the Claims (% of GDP) in Azerbaijan in 2005 to that in 2007?
Provide a succinct answer. 0.7. What is the ratio of the Claims (% of GDP) in Congo (Democratic) in 2005 to that in 2007?
Keep it short and to the point. 0.44. What is the ratio of the Claims (% of GDP) in Seychelles in 2005 to that in 2007?
Offer a terse response. 1.01. What is the ratio of the Claims (% of GDP) of Trinidad and Tobago in 2005 to that in 2007?
Offer a terse response. 1.04. What is the ratio of the Claims (% of GDP) in Azerbaijan in 2005 to that in 2008?
Offer a terse response. 0.65. What is the ratio of the Claims (% of GDP) in Congo (Democratic) in 2005 to that in 2008?
Your answer should be compact. 0.24. What is the ratio of the Claims (% of GDP) in Seychelles in 2005 to that in 2008?
Ensure brevity in your answer.  0.91. What is the ratio of the Claims (% of GDP) in Trinidad and Tobago in 2005 to that in 2008?
Offer a terse response. 1.3. What is the ratio of the Claims (% of GDP) in Azerbaijan in 2005 to that in 2009?
Give a very brief answer. 0.5. What is the ratio of the Claims (% of GDP) in Congo (Democratic) in 2005 to that in 2009?
Your response must be concise. 0.22. What is the ratio of the Claims (% of GDP) of Seychelles in 2005 to that in 2009?
Your answer should be compact. 1.3. What is the ratio of the Claims (% of GDP) in Trinidad and Tobago in 2005 to that in 2009?
Offer a very short reply. 0.86. What is the ratio of the Claims (% of GDP) of Azerbaijan in 2005 to that in 2010?
Offer a very short reply. 0.53. What is the ratio of the Claims (% of GDP) of Congo (Democratic) in 2005 to that in 2010?
Keep it short and to the point. 0.28. What is the ratio of the Claims (% of GDP) of Seychelles in 2005 to that in 2010?
Your answer should be very brief. 1.11. What is the ratio of the Claims (% of GDP) in Trinidad and Tobago in 2005 to that in 2010?
Keep it short and to the point. 0.96. What is the ratio of the Claims (% of GDP) in Azerbaijan in 2005 to that in 2011?
Your answer should be compact. 0.53. What is the ratio of the Claims (% of GDP) of Congo (Democratic) in 2005 to that in 2011?
Keep it short and to the point. 0.24. What is the ratio of the Claims (% of GDP) of Seychelles in 2005 to that in 2011?
Provide a succinct answer. 1.19. What is the ratio of the Claims (% of GDP) of Trinidad and Tobago in 2005 to that in 2011?
Your answer should be compact. 1.11. What is the ratio of the Claims (% of GDP) in Azerbaijan in 2006 to that in 2007?
Your answer should be compact. 0.77. What is the ratio of the Claims (% of GDP) of Congo (Democratic) in 2006 to that in 2007?
Give a very brief answer. 0.78. What is the ratio of the Claims (% of GDP) in Seychelles in 2006 to that in 2007?
Provide a succinct answer. 0.92. What is the ratio of the Claims (% of GDP) of Trinidad and Tobago in 2006 to that in 2007?
Keep it short and to the point. 1.01. What is the ratio of the Claims (% of GDP) in Azerbaijan in 2006 to that in 2008?
Your response must be concise. 0.71. What is the ratio of the Claims (% of GDP) of Congo (Democratic) in 2006 to that in 2008?
Keep it short and to the point. 0.41. What is the ratio of the Claims (% of GDP) of Seychelles in 2006 to that in 2008?
Your answer should be compact. 0.82. What is the ratio of the Claims (% of GDP) of Trinidad and Tobago in 2006 to that in 2008?
Offer a very short reply. 1.27. What is the ratio of the Claims (% of GDP) of Azerbaijan in 2006 to that in 2009?
Your response must be concise. 0.55. What is the ratio of the Claims (% of GDP) of Congo (Democratic) in 2006 to that in 2009?
Make the answer very short. 0.38. What is the ratio of the Claims (% of GDP) of Seychelles in 2006 to that in 2009?
Provide a short and direct response. 1.18. What is the ratio of the Claims (% of GDP) in Trinidad and Tobago in 2006 to that in 2009?
Make the answer very short. 0.84. What is the ratio of the Claims (% of GDP) of Azerbaijan in 2006 to that in 2010?
Ensure brevity in your answer.  0.58. What is the ratio of the Claims (% of GDP) of Congo (Democratic) in 2006 to that in 2010?
Your response must be concise. 0.49. What is the ratio of the Claims (% of GDP) of Seychelles in 2006 to that in 2010?
Your response must be concise. 1.01. What is the ratio of the Claims (% of GDP) of Trinidad and Tobago in 2006 to that in 2010?
Keep it short and to the point. 0.94. What is the ratio of the Claims (% of GDP) in Azerbaijan in 2006 to that in 2011?
Your answer should be compact. 0.59. What is the ratio of the Claims (% of GDP) in Congo (Democratic) in 2006 to that in 2011?
Offer a terse response. 0.43. What is the ratio of the Claims (% of GDP) in Seychelles in 2006 to that in 2011?
Give a very brief answer. 1.08. What is the ratio of the Claims (% of GDP) in Trinidad and Tobago in 2006 to that in 2011?
Provide a succinct answer. 1.09. What is the ratio of the Claims (% of GDP) in Congo (Democratic) in 2007 to that in 2008?
Give a very brief answer. 0.53. What is the ratio of the Claims (% of GDP) in Seychelles in 2007 to that in 2008?
Make the answer very short. 0.89. What is the ratio of the Claims (% of GDP) in Trinidad and Tobago in 2007 to that in 2008?
Your answer should be compact. 1.25. What is the ratio of the Claims (% of GDP) of Azerbaijan in 2007 to that in 2009?
Offer a terse response. 0.71. What is the ratio of the Claims (% of GDP) of Congo (Democratic) in 2007 to that in 2009?
Give a very brief answer. 0.49. What is the ratio of the Claims (% of GDP) in Seychelles in 2007 to that in 2009?
Your response must be concise. 1.28. What is the ratio of the Claims (% of GDP) of Trinidad and Tobago in 2007 to that in 2009?
Your answer should be compact. 0.83. What is the ratio of the Claims (% of GDP) in Azerbaijan in 2007 to that in 2010?
Offer a terse response. 0.75. What is the ratio of the Claims (% of GDP) of Congo (Democratic) in 2007 to that in 2010?
Your answer should be compact. 0.63. What is the ratio of the Claims (% of GDP) of Seychelles in 2007 to that in 2010?
Give a very brief answer. 1.09. What is the ratio of the Claims (% of GDP) of Trinidad and Tobago in 2007 to that in 2010?
Your response must be concise. 0.93. What is the ratio of the Claims (% of GDP) of Azerbaijan in 2007 to that in 2011?
Ensure brevity in your answer.  0.76. What is the ratio of the Claims (% of GDP) in Congo (Democratic) in 2007 to that in 2011?
Ensure brevity in your answer.  0.55. What is the ratio of the Claims (% of GDP) of Seychelles in 2007 to that in 2011?
Make the answer very short. 1.17. What is the ratio of the Claims (% of GDP) of Trinidad and Tobago in 2007 to that in 2011?
Offer a very short reply. 1.07. What is the ratio of the Claims (% of GDP) in Azerbaijan in 2008 to that in 2009?
Your answer should be compact. 0.77. What is the ratio of the Claims (% of GDP) of Congo (Democratic) in 2008 to that in 2009?
Provide a short and direct response. 0.92. What is the ratio of the Claims (% of GDP) of Seychelles in 2008 to that in 2009?
Provide a succinct answer. 1.43. What is the ratio of the Claims (% of GDP) in Trinidad and Tobago in 2008 to that in 2009?
Make the answer very short. 0.66. What is the ratio of the Claims (% of GDP) of Azerbaijan in 2008 to that in 2010?
Offer a terse response. 0.81. What is the ratio of the Claims (% of GDP) of Congo (Democratic) in 2008 to that in 2010?
Provide a short and direct response. 1.19. What is the ratio of the Claims (% of GDP) in Seychelles in 2008 to that in 2010?
Your answer should be very brief. 1.22. What is the ratio of the Claims (% of GDP) of Trinidad and Tobago in 2008 to that in 2010?
Offer a terse response. 0.74. What is the ratio of the Claims (% of GDP) in Azerbaijan in 2008 to that in 2011?
Ensure brevity in your answer.  0.82. What is the ratio of the Claims (% of GDP) in Congo (Democratic) in 2008 to that in 2011?
Offer a terse response. 1.03. What is the ratio of the Claims (% of GDP) of Seychelles in 2008 to that in 2011?
Your response must be concise. 1.31. What is the ratio of the Claims (% of GDP) of Trinidad and Tobago in 2008 to that in 2011?
Your answer should be compact. 0.86. What is the ratio of the Claims (% of GDP) of Azerbaijan in 2009 to that in 2010?
Provide a short and direct response. 1.06. What is the ratio of the Claims (% of GDP) in Congo (Democratic) in 2009 to that in 2010?
Your answer should be very brief. 1.3. What is the ratio of the Claims (% of GDP) in Seychelles in 2009 to that in 2010?
Offer a terse response. 0.85. What is the ratio of the Claims (% of GDP) of Trinidad and Tobago in 2009 to that in 2010?
Your answer should be very brief. 1.12. What is the ratio of the Claims (% of GDP) in Azerbaijan in 2009 to that in 2011?
Keep it short and to the point. 1.07. What is the ratio of the Claims (% of GDP) in Congo (Democratic) in 2009 to that in 2011?
Offer a terse response. 1.12. What is the ratio of the Claims (% of GDP) in Seychelles in 2009 to that in 2011?
Provide a succinct answer. 0.91. What is the ratio of the Claims (% of GDP) of Trinidad and Tobago in 2009 to that in 2011?
Make the answer very short. 1.29. What is the ratio of the Claims (% of GDP) of Azerbaijan in 2010 to that in 2011?
Provide a succinct answer. 1.01. What is the ratio of the Claims (% of GDP) in Congo (Democratic) in 2010 to that in 2011?
Ensure brevity in your answer.  0.87. What is the ratio of the Claims (% of GDP) of Seychelles in 2010 to that in 2011?
Offer a very short reply. 1.07. What is the ratio of the Claims (% of GDP) in Trinidad and Tobago in 2010 to that in 2011?
Your answer should be compact. 1.16. What is the difference between the highest and the second highest Claims (% of GDP) in Azerbaijan?
Keep it short and to the point. 1.24. What is the difference between the highest and the second highest Claims (% of GDP) of Congo (Democratic)?
Keep it short and to the point. 0.48. What is the difference between the highest and the second highest Claims (% of GDP) of Seychelles?
Offer a terse response. 3.21. What is the difference between the highest and the second highest Claims (% of GDP) in Trinidad and Tobago?
Give a very brief answer. 4.94. What is the difference between the highest and the lowest Claims (% of GDP) of Azerbaijan?
Ensure brevity in your answer.  11.85. What is the difference between the highest and the lowest Claims (% of GDP) of Congo (Democratic)?
Provide a short and direct response. 4.47. What is the difference between the highest and the lowest Claims (% of GDP) in Seychelles?
Your answer should be very brief. 10.29. What is the difference between the highest and the lowest Claims (% of GDP) in Trinidad and Tobago?
Your answer should be compact. 15.76. 